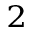Convert formula to latex. <formula><loc_0><loc_0><loc_500><loc_500>_ { 2 }</formula> 